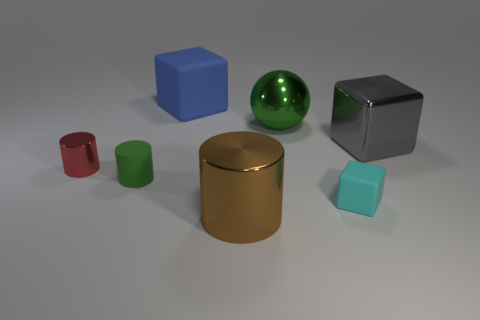Subtract 1 cylinders. How many cylinders are left? 2 Add 3 green rubber cylinders. How many objects exist? 10 Subtract all cylinders. How many objects are left? 4 Add 1 metallic things. How many metallic things are left? 5 Add 5 large green objects. How many large green objects exist? 6 Subtract 0 blue balls. How many objects are left? 7 Subtract all large purple spheres. Subtract all tiny cubes. How many objects are left? 6 